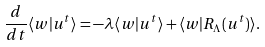<formula> <loc_0><loc_0><loc_500><loc_500>\frac { d } { d t } \langle w | u ^ { t } \rangle = - \lambda \langle w | u ^ { t } \rangle + \langle w | R _ { \Lambda } ( u ^ { t } ) \rangle .</formula> 